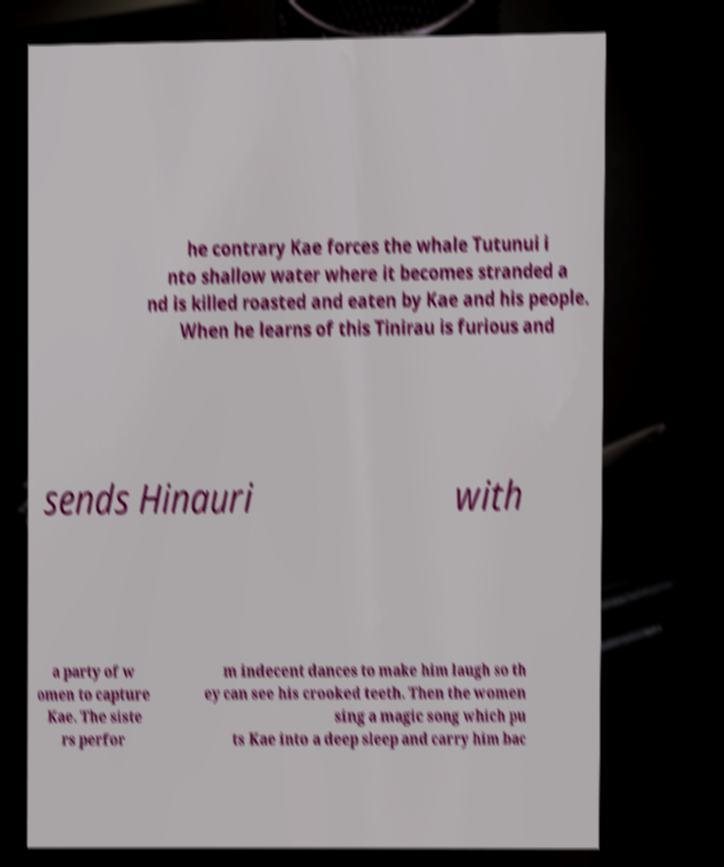Can you accurately transcribe the text from the provided image for me? he contrary Kae forces the whale Tutunui i nto shallow water where it becomes stranded a nd is killed roasted and eaten by Kae and his people. When he learns of this Tinirau is furious and sends Hinauri with a party of w omen to capture Kae. The siste rs perfor m indecent dances to make him laugh so th ey can see his crooked teeth. Then the women sing a magic song which pu ts Kae into a deep sleep and carry him bac 